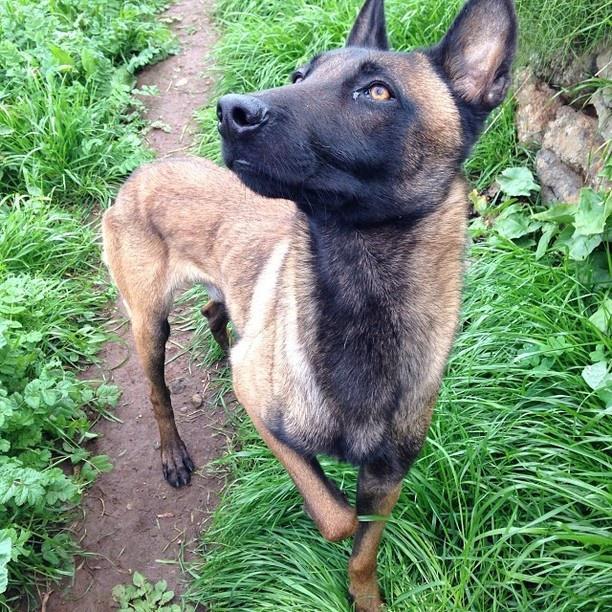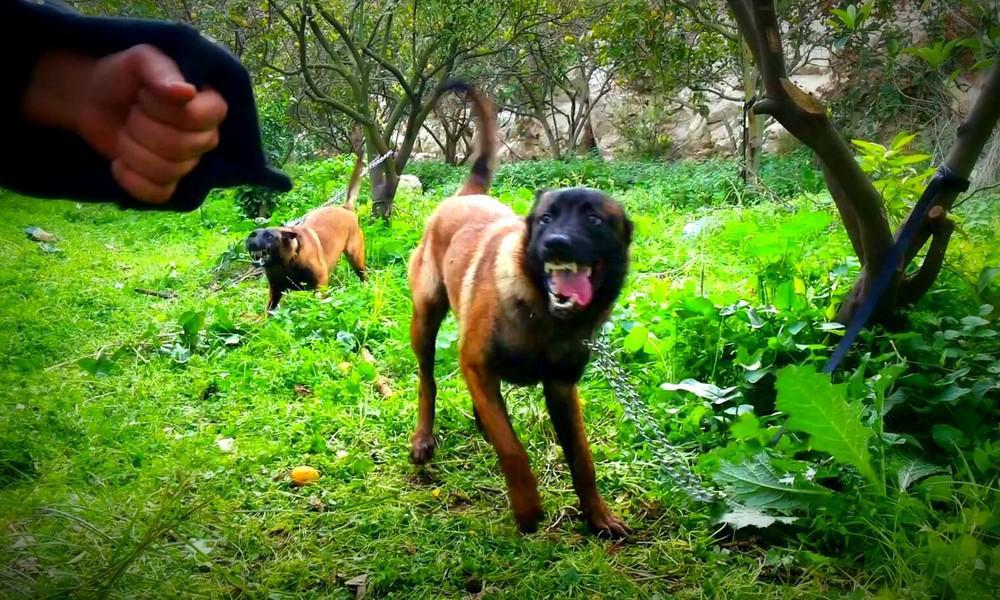The first image is the image on the left, the second image is the image on the right. Evaluate the accuracy of this statement regarding the images: "In one of the images there is a dog attached to a leash.". Is it true? Answer yes or no. No. The first image is the image on the left, the second image is the image on the right. Analyze the images presented: Is the assertion "An image shows exactly one german shepherd, which is sitting on the grass." valid? Answer yes or no. No. 